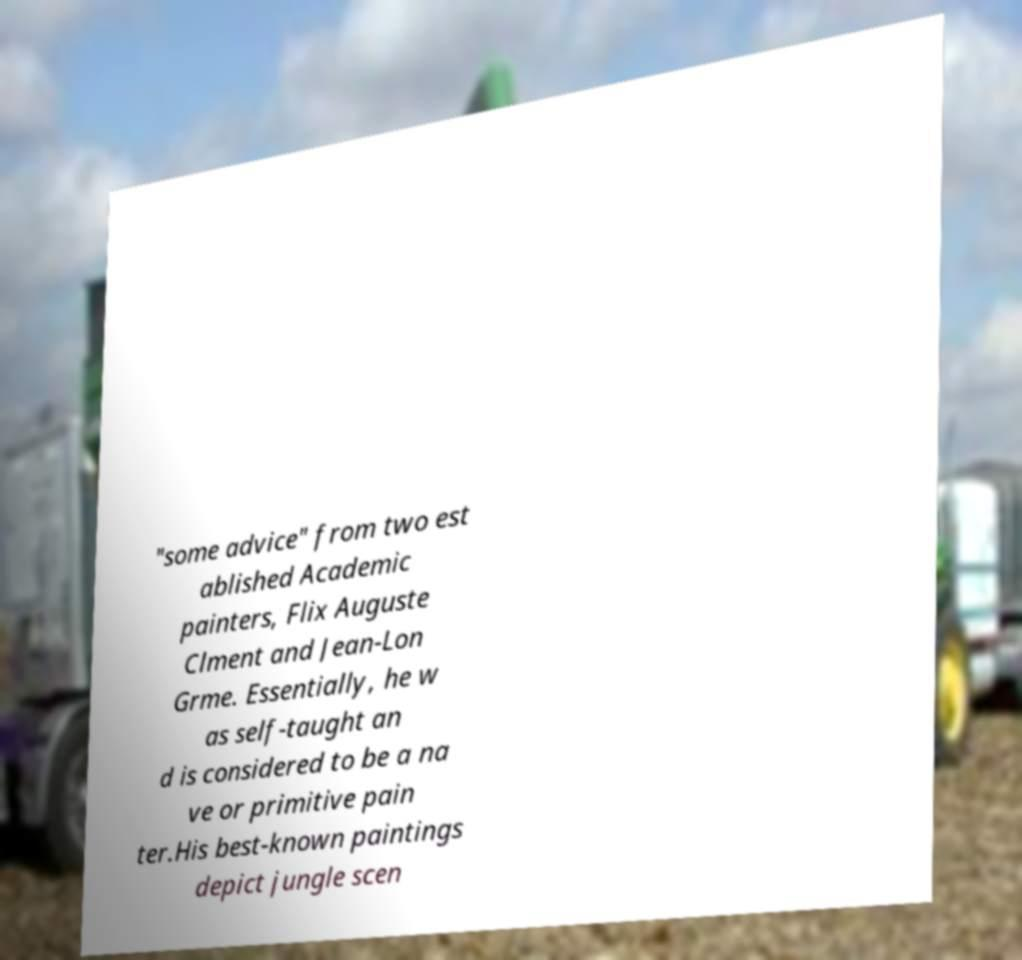Can you accurately transcribe the text from the provided image for me? "some advice" from two est ablished Academic painters, Flix Auguste Clment and Jean-Lon Grme. Essentially, he w as self-taught an d is considered to be a na ve or primitive pain ter.His best-known paintings depict jungle scen 